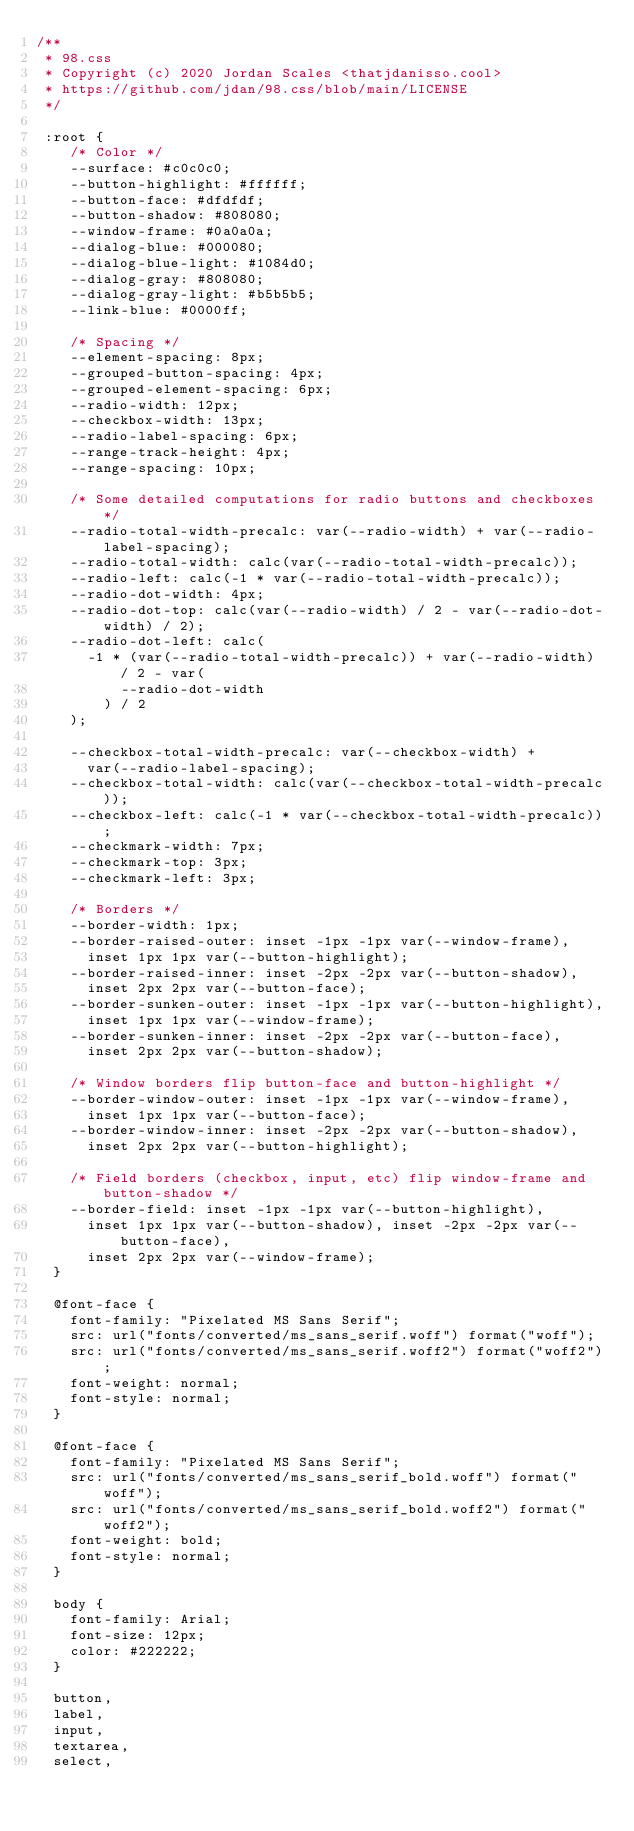Convert code to text. <code><loc_0><loc_0><loc_500><loc_500><_CSS_>/**
 * 98.css
 * Copyright (c) 2020 Jordan Scales <thatjdanisso.cool>
 * https://github.com/jdan/98.css/blob/main/LICENSE
 */

 :root {
    /* Color */
    --surface: #c0c0c0;
    --button-highlight: #ffffff;
    --button-face: #dfdfdf;
    --button-shadow: #808080;
    --window-frame: #0a0a0a;
    --dialog-blue: #000080;
    --dialog-blue-light: #1084d0;
    --dialog-gray: #808080;
    --dialog-gray-light: #b5b5b5;
    --link-blue: #0000ff;
  
    /* Spacing */
    --element-spacing: 8px;
    --grouped-button-spacing: 4px;
    --grouped-element-spacing: 6px;
    --radio-width: 12px;
    --checkbox-width: 13px;
    --radio-label-spacing: 6px;
    --range-track-height: 4px;
    --range-spacing: 10px;
  
    /* Some detailed computations for radio buttons and checkboxes */
    --radio-total-width-precalc: var(--radio-width) + var(--radio-label-spacing);
    --radio-total-width: calc(var(--radio-total-width-precalc));
    --radio-left: calc(-1 * var(--radio-total-width-precalc));
    --radio-dot-width: 4px;
    --radio-dot-top: calc(var(--radio-width) / 2 - var(--radio-dot-width) / 2);
    --radio-dot-left: calc(
      -1 * (var(--radio-total-width-precalc)) + var(--radio-width) / 2 - var(
          --radio-dot-width
        ) / 2
    );
  
    --checkbox-total-width-precalc: var(--checkbox-width) +
      var(--radio-label-spacing);
    --checkbox-total-width: calc(var(--checkbox-total-width-precalc));
    --checkbox-left: calc(-1 * var(--checkbox-total-width-precalc));
    --checkmark-width: 7px;
    --checkmark-top: 3px;
    --checkmark-left: 3px;
  
    /* Borders */
    --border-width: 1px;
    --border-raised-outer: inset -1px -1px var(--window-frame),
      inset 1px 1px var(--button-highlight);
    --border-raised-inner: inset -2px -2px var(--button-shadow),
      inset 2px 2px var(--button-face);
    --border-sunken-outer: inset -1px -1px var(--button-highlight),
      inset 1px 1px var(--window-frame);
    --border-sunken-inner: inset -2px -2px var(--button-face),
      inset 2px 2px var(--button-shadow);
  
    /* Window borders flip button-face and button-highlight */
    --border-window-outer: inset -1px -1px var(--window-frame),
      inset 1px 1px var(--button-face);
    --border-window-inner: inset -2px -2px var(--button-shadow),
      inset 2px 2px var(--button-highlight);
  
    /* Field borders (checkbox, input, etc) flip window-frame and button-shadow */
    --border-field: inset -1px -1px var(--button-highlight),
      inset 1px 1px var(--button-shadow), inset -2px -2px var(--button-face),
      inset 2px 2px var(--window-frame);
  }
  
  @font-face {
    font-family: "Pixelated MS Sans Serif";
    src: url("fonts/converted/ms_sans_serif.woff") format("woff");
    src: url("fonts/converted/ms_sans_serif.woff2") format("woff2");
    font-weight: normal;
    font-style: normal;
  }
  
  @font-face {
    font-family: "Pixelated MS Sans Serif";
    src: url("fonts/converted/ms_sans_serif_bold.woff") format("woff");
    src: url("fonts/converted/ms_sans_serif_bold.woff2") format("woff2");
    font-weight: bold;
    font-style: normal;
  }
  
  body {
    font-family: Arial;
    font-size: 12px;
    color: #222222;
  }
  
  button,
  label,
  input,
  textarea,
  select,</code> 